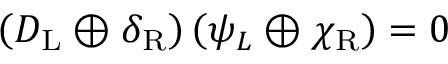<formula> <loc_0><loc_0><loc_500><loc_500>\left ( D _ { L } \oplus \delta _ { R } \right ) \left ( \psi _ { L } \oplus \chi _ { R } \right ) = 0</formula> 